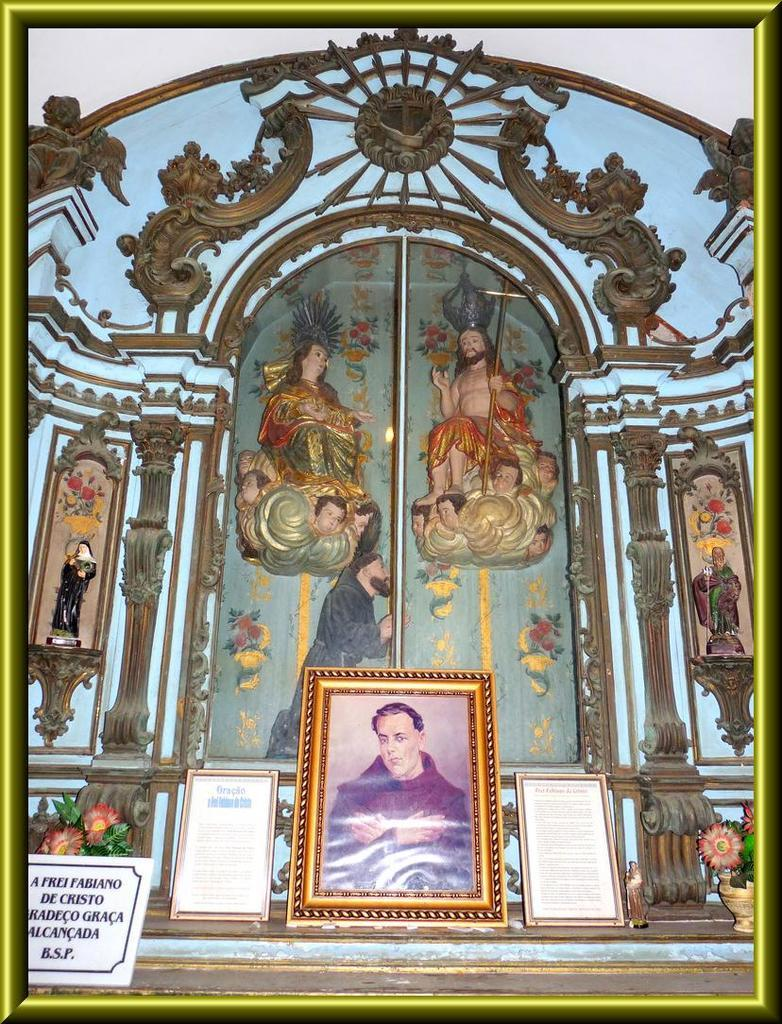What objects are present in the image that hold pictures? There are photo frames in the image that hold pictures. What can be seen inside the photo frames? There are photos inside the photo frames. What type of object is present in the image that is not a photo frame or a photo? There is a statue in the image. What type of arch can be seen supporting the statue in the image? There is no arch present in the image; the statue is not supported by an arch. 